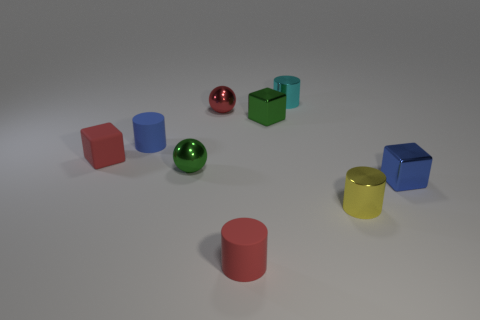Add 1 yellow spheres. How many objects exist? 10 Subtract all cylinders. How many objects are left? 5 Subtract all tiny brown matte balls. Subtract all red blocks. How many objects are left? 8 Add 9 red metallic things. How many red metallic things are left? 10 Add 3 yellow balls. How many yellow balls exist? 3 Subtract 1 blue cylinders. How many objects are left? 8 